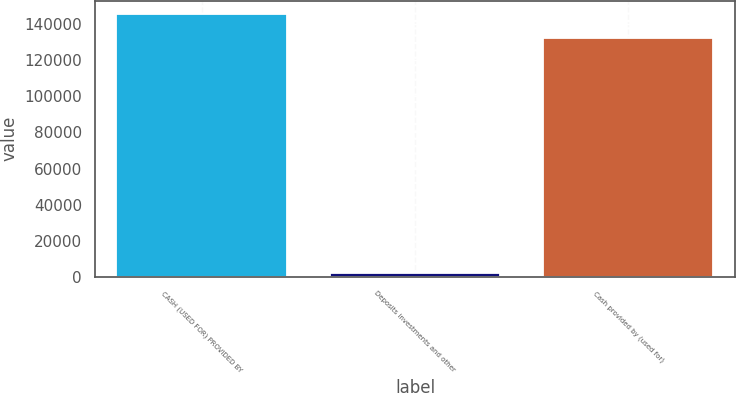Convert chart. <chart><loc_0><loc_0><loc_500><loc_500><bar_chart><fcel>CASH (USED FOR) PROVIDED BY<fcel>Deposits investments and other<fcel>Cash provided by (used for)<nl><fcel>145794<fcel>2000<fcel>132540<nl></chart> 